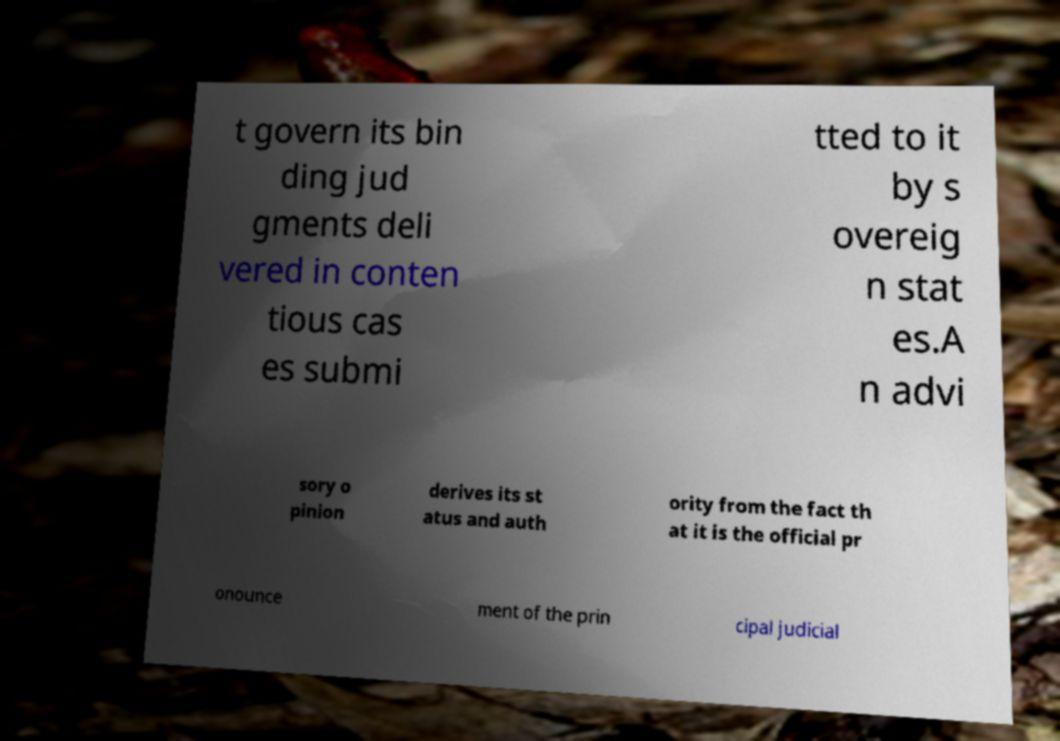Please identify and transcribe the text found in this image. t govern its bin ding jud gments deli vered in conten tious cas es submi tted to it by s overeig n stat es.A n advi sory o pinion derives its st atus and auth ority from the fact th at it is the official pr onounce ment of the prin cipal judicial 